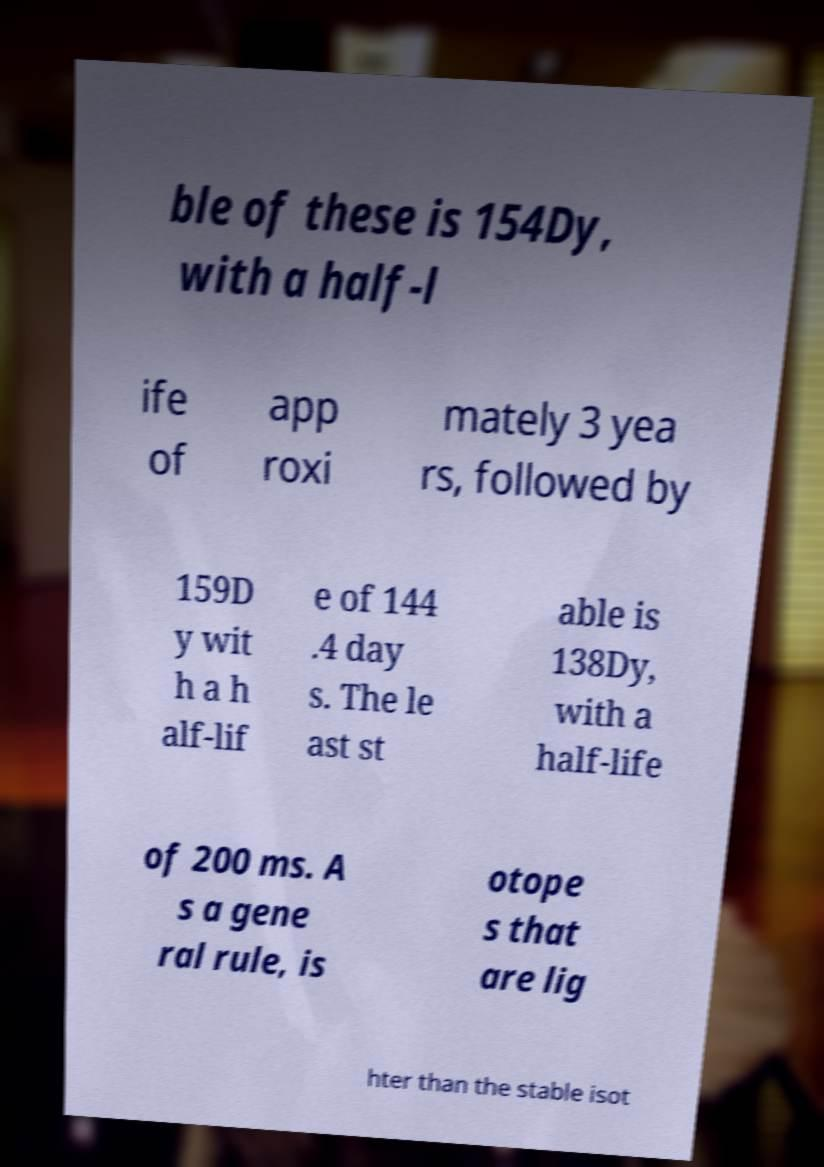Could you assist in decoding the text presented in this image and type it out clearly? ble of these is 154Dy, with a half-l ife of app roxi mately 3 yea rs, followed by 159D y wit h a h alf-lif e of 144 .4 day s. The le ast st able is 138Dy, with a half-life of 200 ms. A s a gene ral rule, is otope s that are lig hter than the stable isot 